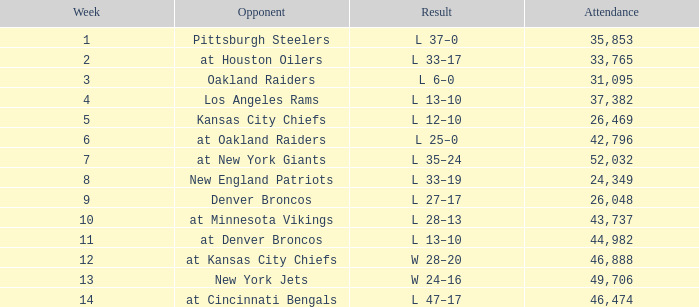When the opposing team was the los angeles rams and the attendance was over 37,382, which week had the highest number? None. 